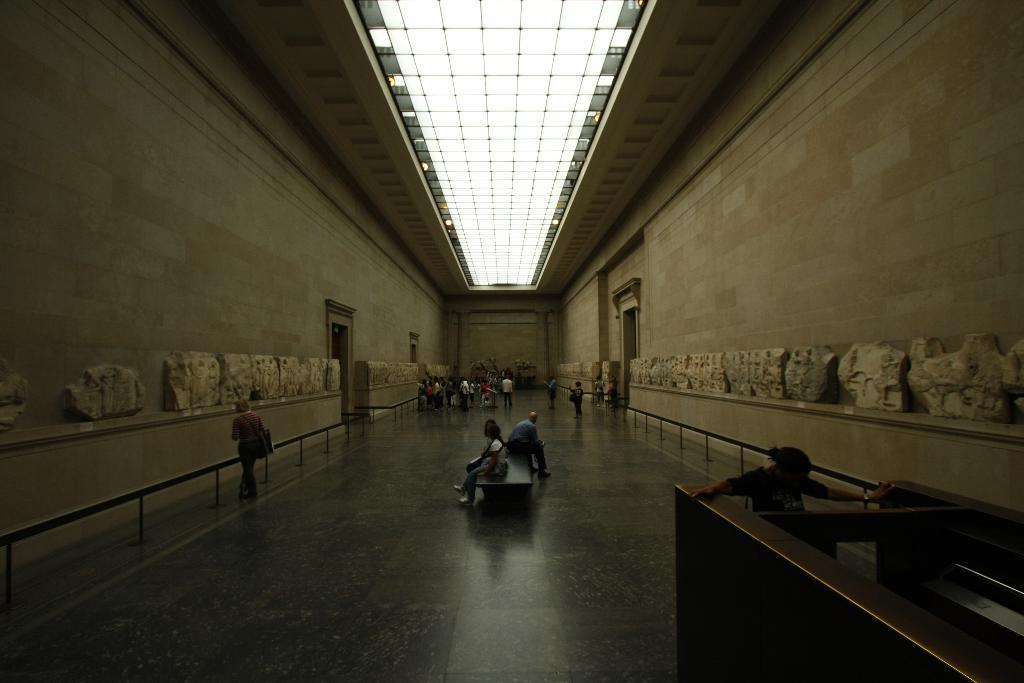How many people are in the image? There are people in the image, but the exact number is not specified. What are some of the people doing in the image? Some people are sitting on a platform in the image. What can be seen around the platform in the image? There is a railing, walls, a ceiling, lights, and a floor in the image. Can you describe the object in the image? The object in the image is not described in detail, so it cannot be accurately described. What type of sweater is the scarecrow wearing in the image? There is no scarecrow or sweater present in the image. How many apples are on the tree in the image? There is no tree or apples mentioned in the image. 